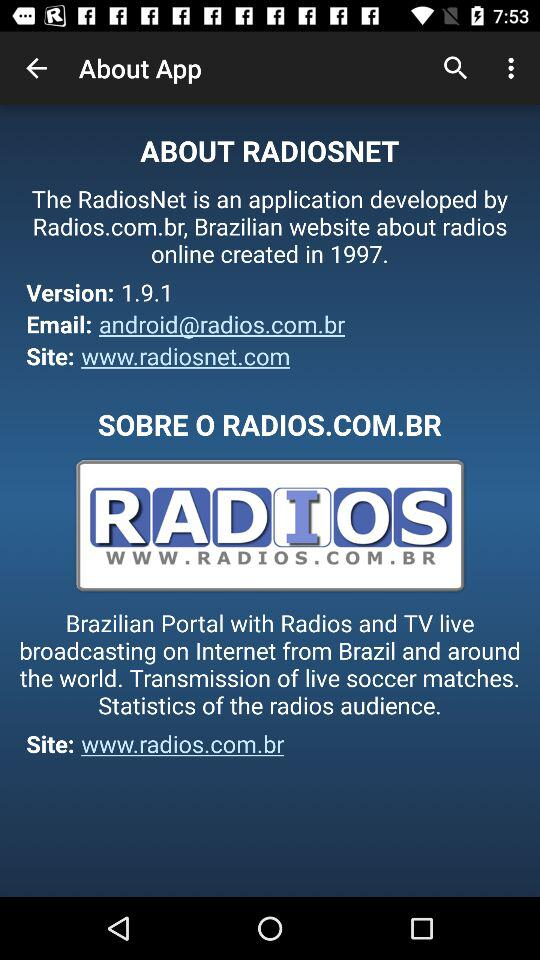What is the version of "RADIOSNET"? The version is 1.9.1. 